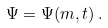<formula> <loc_0><loc_0><loc_500><loc_500>\Psi = \Psi ( m , t ) \, .</formula> 